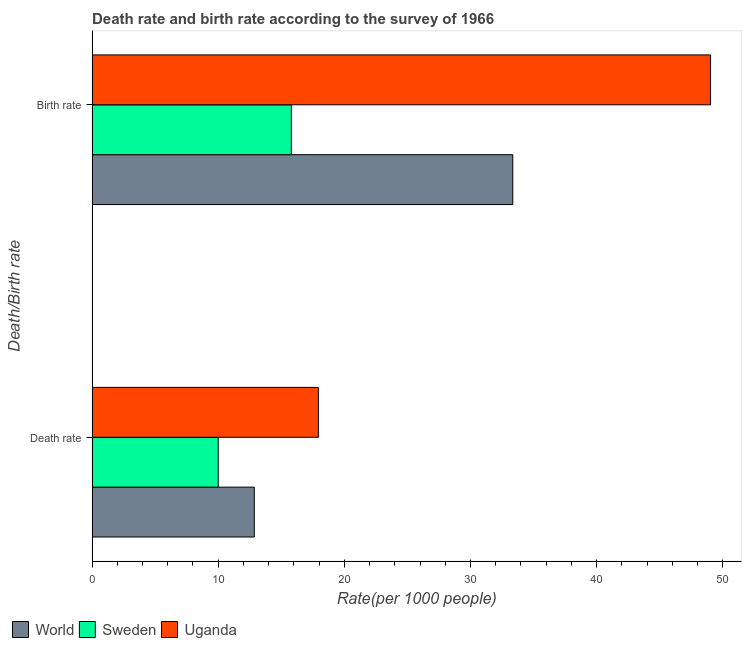How many different coloured bars are there?
Offer a terse response. 3. How many groups of bars are there?
Offer a very short reply. 2. Are the number of bars per tick equal to the number of legend labels?
Ensure brevity in your answer.  Yes. Are the number of bars on each tick of the Y-axis equal?
Make the answer very short. Yes. What is the label of the 1st group of bars from the top?
Keep it short and to the point. Birth rate. What is the birth rate in World?
Provide a short and direct response. 33.36. Across all countries, what is the maximum death rate?
Offer a very short reply. 17.94. Across all countries, what is the minimum birth rate?
Make the answer very short. 15.8. In which country was the death rate maximum?
Your answer should be very brief. Uganda. What is the total death rate in the graph?
Provide a succinct answer. 40.8. What is the difference between the death rate in World and that in Uganda?
Provide a succinct answer. -5.08. What is the difference between the birth rate in Sweden and the death rate in World?
Give a very brief answer. 2.94. What is the average birth rate per country?
Provide a short and direct response. 32.73. What is the difference between the death rate and birth rate in Uganda?
Make the answer very short. -31.1. In how many countries, is the birth rate greater than 14 ?
Make the answer very short. 3. What is the ratio of the birth rate in World to that in Uganda?
Offer a terse response. 0.68. What does the 3rd bar from the bottom in Birth rate represents?
Your answer should be very brief. Uganda. How many bars are there?
Your answer should be very brief. 6. Are all the bars in the graph horizontal?
Offer a terse response. Yes. What is the difference between two consecutive major ticks on the X-axis?
Offer a very short reply. 10. Are the values on the major ticks of X-axis written in scientific E-notation?
Offer a terse response. No. Does the graph contain any zero values?
Keep it short and to the point. No. Where does the legend appear in the graph?
Offer a very short reply. Bottom left. How are the legend labels stacked?
Offer a terse response. Horizontal. What is the title of the graph?
Offer a very short reply. Death rate and birth rate according to the survey of 1966. Does "Somalia" appear as one of the legend labels in the graph?
Provide a short and direct response. No. What is the label or title of the X-axis?
Provide a short and direct response. Rate(per 1000 people). What is the label or title of the Y-axis?
Provide a succinct answer. Death/Birth rate. What is the Rate(per 1000 people) of World in Death rate?
Provide a short and direct response. 12.86. What is the Rate(per 1000 people) of Sweden in Death rate?
Ensure brevity in your answer.  10. What is the Rate(per 1000 people) in Uganda in Death rate?
Your answer should be compact. 17.94. What is the Rate(per 1000 people) in World in Birth rate?
Your answer should be compact. 33.36. What is the Rate(per 1000 people) of Uganda in Birth rate?
Offer a terse response. 49.04. Across all Death/Birth rate, what is the maximum Rate(per 1000 people) in World?
Offer a very short reply. 33.36. Across all Death/Birth rate, what is the maximum Rate(per 1000 people) in Sweden?
Provide a short and direct response. 15.8. Across all Death/Birth rate, what is the maximum Rate(per 1000 people) in Uganda?
Give a very brief answer. 49.04. Across all Death/Birth rate, what is the minimum Rate(per 1000 people) of World?
Make the answer very short. 12.86. Across all Death/Birth rate, what is the minimum Rate(per 1000 people) of Sweden?
Give a very brief answer. 10. Across all Death/Birth rate, what is the minimum Rate(per 1000 people) of Uganda?
Ensure brevity in your answer.  17.94. What is the total Rate(per 1000 people) of World in the graph?
Give a very brief answer. 46.22. What is the total Rate(per 1000 people) of Sweden in the graph?
Keep it short and to the point. 25.8. What is the total Rate(per 1000 people) of Uganda in the graph?
Your answer should be very brief. 66.98. What is the difference between the Rate(per 1000 people) in World in Death rate and that in Birth rate?
Keep it short and to the point. -20.5. What is the difference between the Rate(per 1000 people) of Uganda in Death rate and that in Birth rate?
Make the answer very short. -31.1. What is the difference between the Rate(per 1000 people) of World in Death rate and the Rate(per 1000 people) of Sweden in Birth rate?
Offer a terse response. -2.94. What is the difference between the Rate(per 1000 people) in World in Death rate and the Rate(per 1000 people) in Uganda in Birth rate?
Your response must be concise. -36.18. What is the difference between the Rate(per 1000 people) in Sweden in Death rate and the Rate(per 1000 people) in Uganda in Birth rate?
Ensure brevity in your answer.  -39.04. What is the average Rate(per 1000 people) of World per Death/Birth rate?
Provide a succinct answer. 23.11. What is the average Rate(per 1000 people) of Uganda per Death/Birth rate?
Offer a terse response. 33.49. What is the difference between the Rate(per 1000 people) in World and Rate(per 1000 people) in Sweden in Death rate?
Keep it short and to the point. 2.86. What is the difference between the Rate(per 1000 people) in World and Rate(per 1000 people) in Uganda in Death rate?
Your response must be concise. -5.08. What is the difference between the Rate(per 1000 people) of Sweden and Rate(per 1000 people) of Uganda in Death rate?
Ensure brevity in your answer.  -7.94. What is the difference between the Rate(per 1000 people) in World and Rate(per 1000 people) in Sweden in Birth rate?
Offer a terse response. 17.56. What is the difference between the Rate(per 1000 people) of World and Rate(per 1000 people) of Uganda in Birth rate?
Ensure brevity in your answer.  -15.68. What is the difference between the Rate(per 1000 people) of Sweden and Rate(per 1000 people) of Uganda in Birth rate?
Your answer should be very brief. -33.24. What is the ratio of the Rate(per 1000 people) of World in Death rate to that in Birth rate?
Your answer should be compact. 0.39. What is the ratio of the Rate(per 1000 people) in Sweden in Death rate to that in Birth rate?
Your answer should be very brief. 0.63. What is the ratio of the Rate(per 1000 people) of Uganda in Death rate to that in Birth rate?
Offer a terse response. 0.37. What is the difference between the highest and the second highest Rate(per 1000 people) in World?
Your answer should be very brief. 20.5. What is the difference between the highest and the second highest Rate(per 1000 people) in Sweden?
Your answer should be compact. 5.8. What is the difference between the highest and the second highest Rate(per 1000 people) in Uganda?
Your answer should be very brief. 31.1. What is the difference between the highest and the lowest Rate(per 1000 people) of World?
Your answer should be compact. 20.5. What is the difference between the highest and the lowest Rate(per 1000 people) in Sweden?
Your response must be concise. 5.8. What is the difference between the highest and the lowest Rate(per 1000 people) of Uganda?
Offer a terse response. 31.1. 